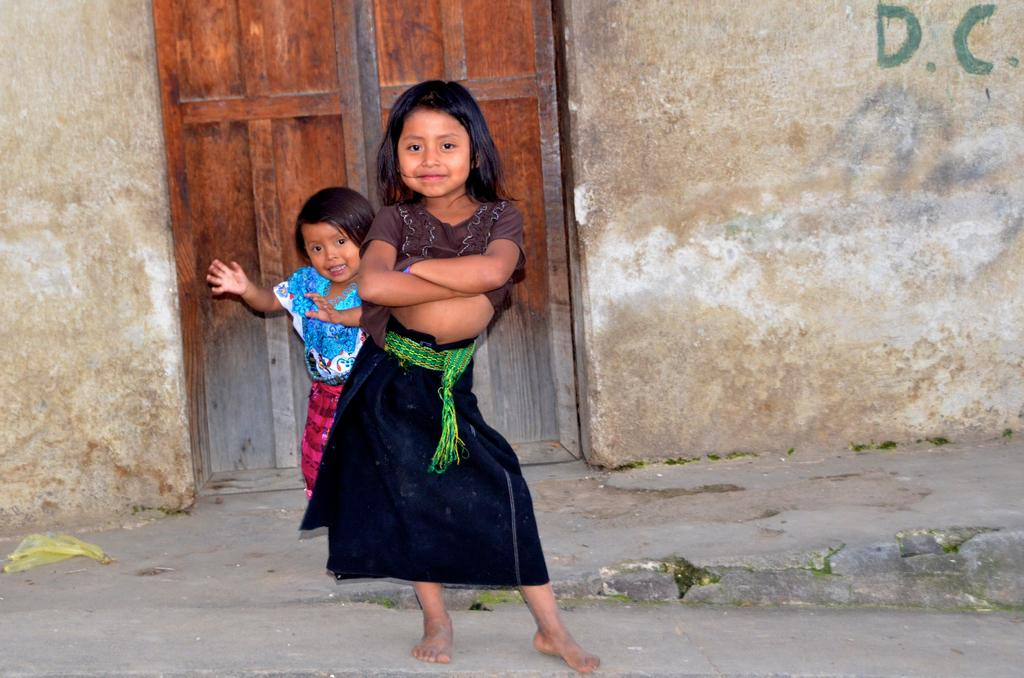How many girls are in the image? There are two small girls in the image. What are the girls doing in the image? The girls are standing on a path, and they have different poses. What can be seen behind the girls in the image? There is a wall visible in the image, and there is a door in the wall. What type of suit is the girl on the left wearing in the image? There is no suit visible in the image; the girls are not wearing any clothing items mentioned in the facts. 